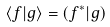Convert formula to latex. <formula><loc_0><loc_0><loc_500><loc_500>\left \langle f | g \right \rangle = \left ( f ^ { * } | g \right )</formula> 